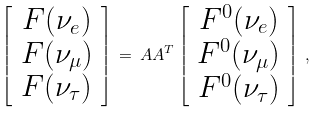Convert formula to latex. <formula><loc_0><loc_0><loc_500><loc_500>\left [ \begin{array} { c } F ( \nu _ { e } ) \\ F ( \nu _ { \mu } ) \\ F ( \nu _ { \tau } ) \end{array} \right ] \, = \, A A ^ { T } \left [ \begin{array} { c c } F ^ { 0 } ( \nu _ { e } ) \\ F ^ { 0 } ( \nu _ { \mu } ) \\ F ^ { 0 } ( \nu _ { \tau } ) \end{array} \right ] \, ,</formula> 